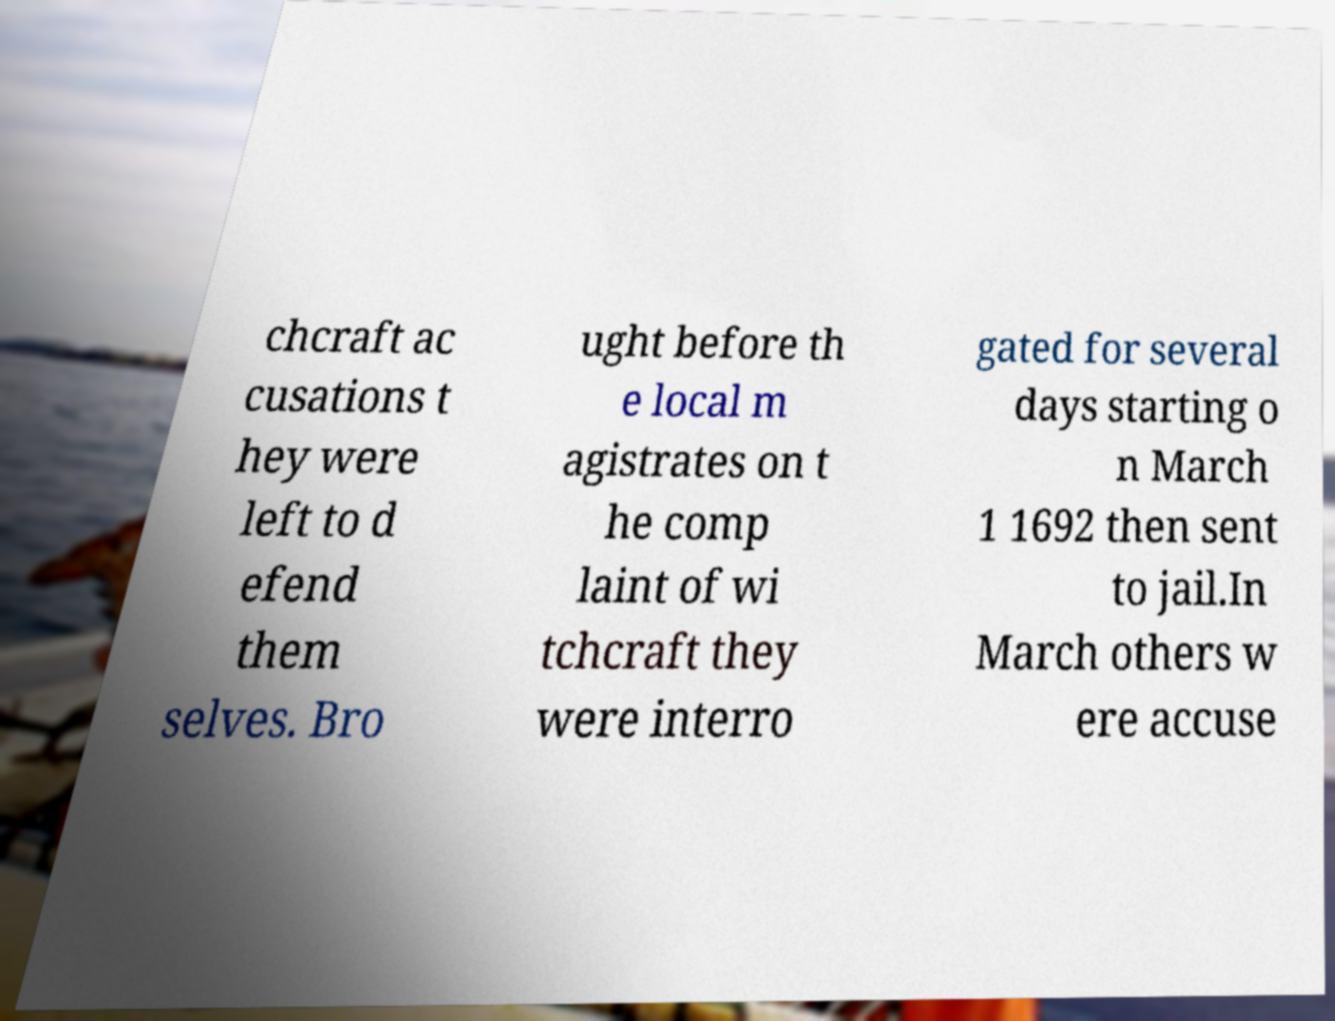For documentation purposes, I need the text within this image transcribed. Could you provide that? chcraft ac cusations t hey were left to d efend them selves. Bro ught before th e local m agistrates on t he comp laint of wi tchcraft they were interro gated for several days starting o n March 1 1692 then sent to jail.In March others w ere accuse 